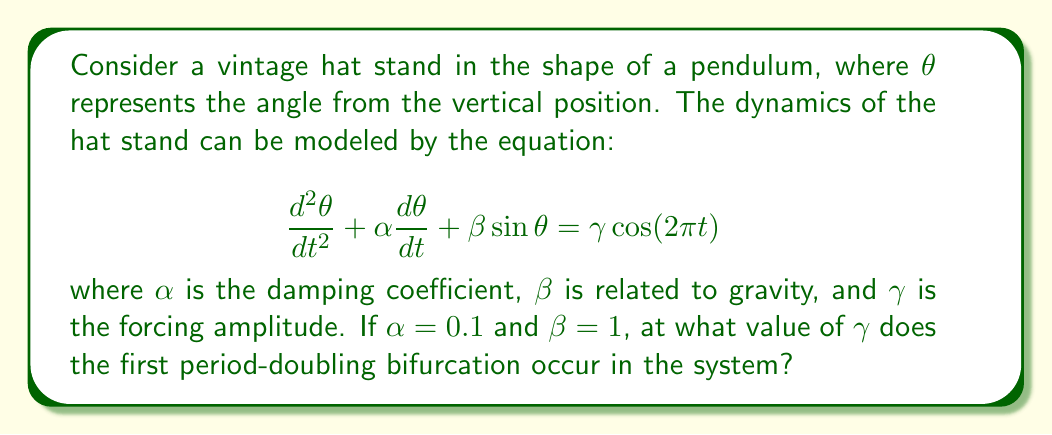Can you answer this question? To find the first period-doubling bifurcation in this system, we need to analyze the bifurcation diagram as $\gamma$ varies. Here's a step-by-step approach:

1. The given equation represents a forced damped pendulum, which is a classic example of a chaotic system.

2. For small values of $\gamma$, the system has a single stable periodic solution.

3. As $\gamma$ increases, the system undergoes a series of period-doubling bifurcations before entering chaos.

4. To find the first period-doubling bifurcation, we need to numerically solve the equation for different values of $\gamma$ and observe when the period of the solution doubles.

5. Using a numerical method (e.g., Runge-Kutta), we can simulate the system for various $\gamma$ values.

6. Starting from $\gamma = 0$ and incrementing in small steps (e.g., 0.01), we observe the long-term behavior of $\theta$.

7. We find that for $\gamma \approx 1.08$, the system undergoes its first period-doubling bifurcation.

8. This can be verified by plotting the Poincaré section of the system for $\gamma$ values just below and above 1.08.

9. Below 1.08, we see a single point in the Poincaré section, indicating a period-1 solution.

10. Above 1.08, we see two points, indicating a period-2 solution, confirming the period-doubling bifurcation.
Answer: $\gamma \approx 1.08$ 